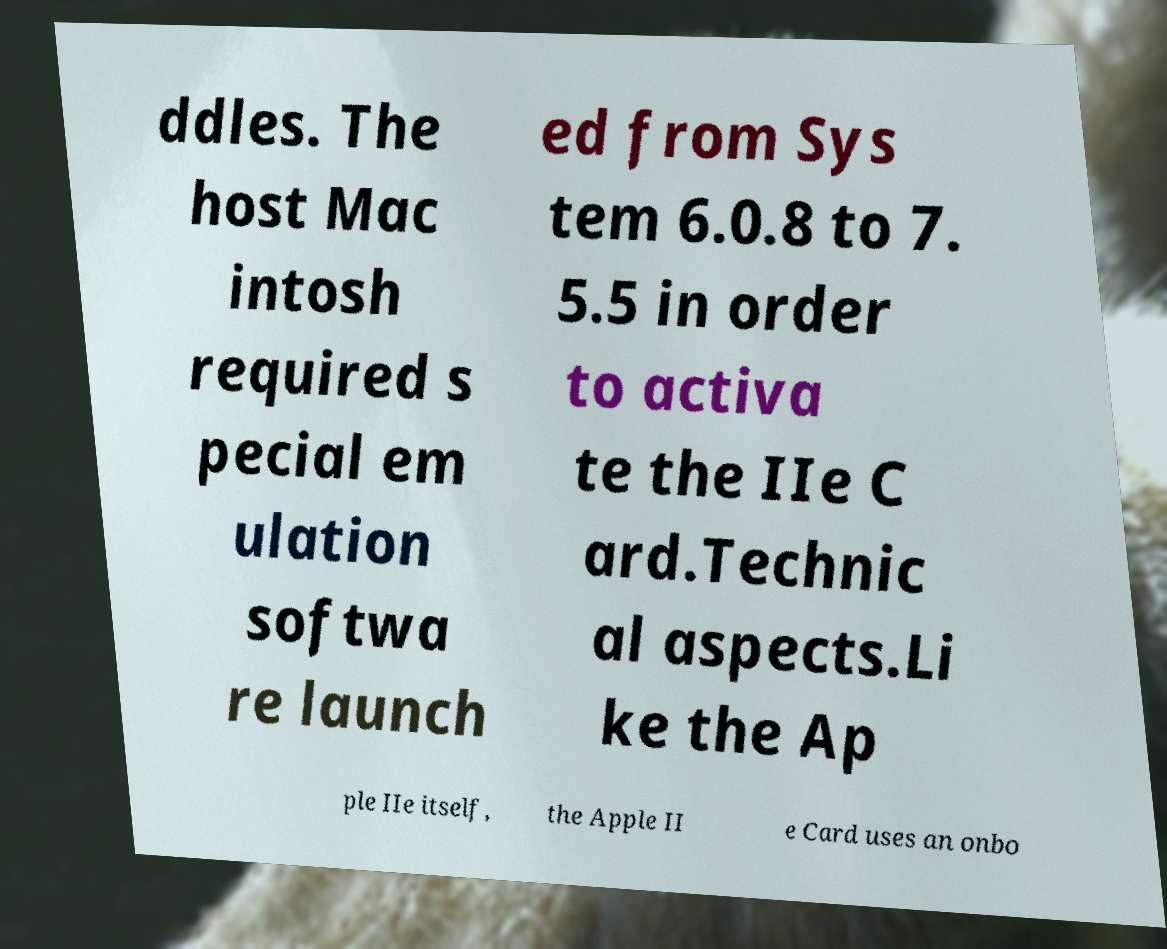I need the written content from this picture converted into text. Can you do that? ddles. The host Mac intosh required s pecial em ulation softwa re launch ed from Sys tem 6.0.8 to 7. 5.5 in order to activa te the IIe C ard.Technic al aspects.Li ke the Ap ple IIe itself, the Apple II e Card uses an onbo 